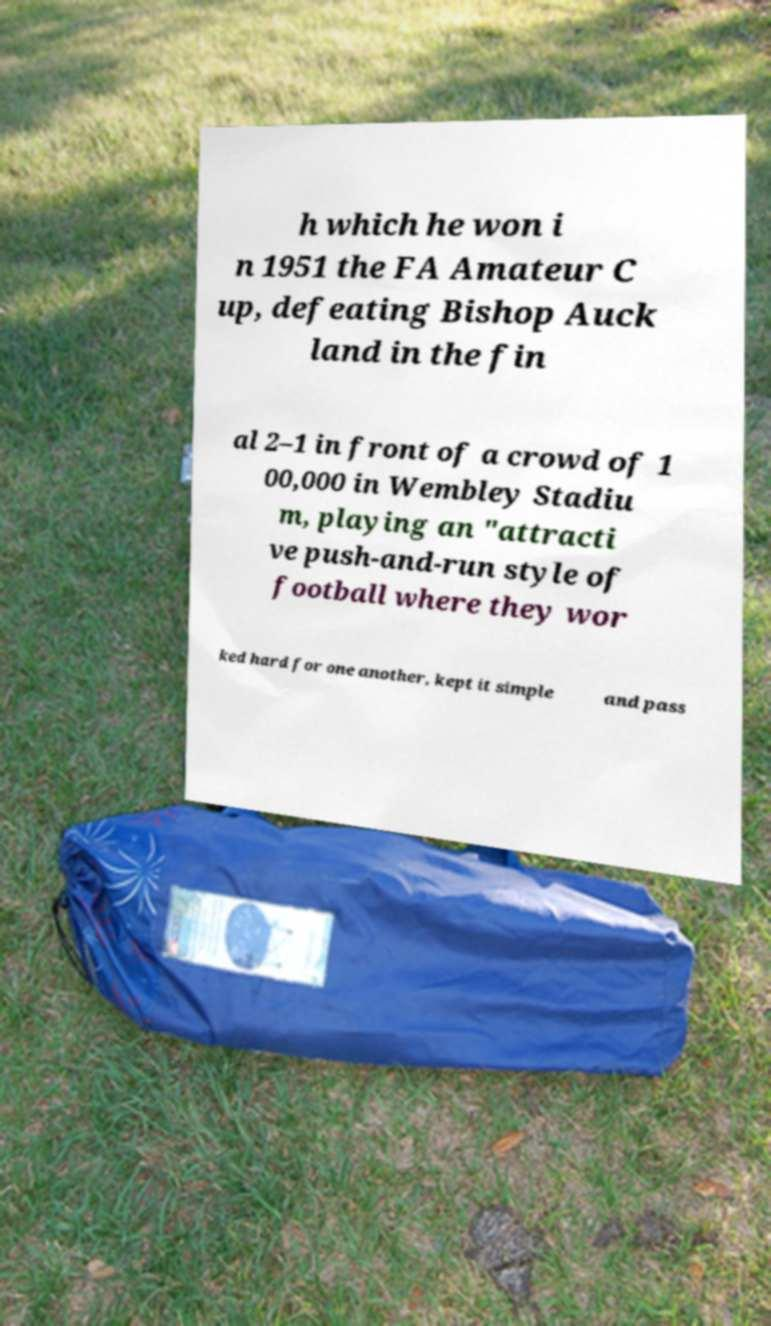Please identify and transcribe the text found in this image. h which he won i n 1951 the FA Amateur C up, defeating Bishop Auck land in the fin al 2–1 in front of a crowd of 1 00,000 in Wembley Stadiu m, playing an "attracti ve push-and-run style of football where they wor ked hard for one another, kept it simple and pass 